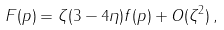<formula> <loc_0><loc_0><loc_500><loc_500>F ( p ) = \zeta ( 3 - 4 \eta ) f ( p ) + O ( \zeta ^ { 2 } ) \, ,</formula> 